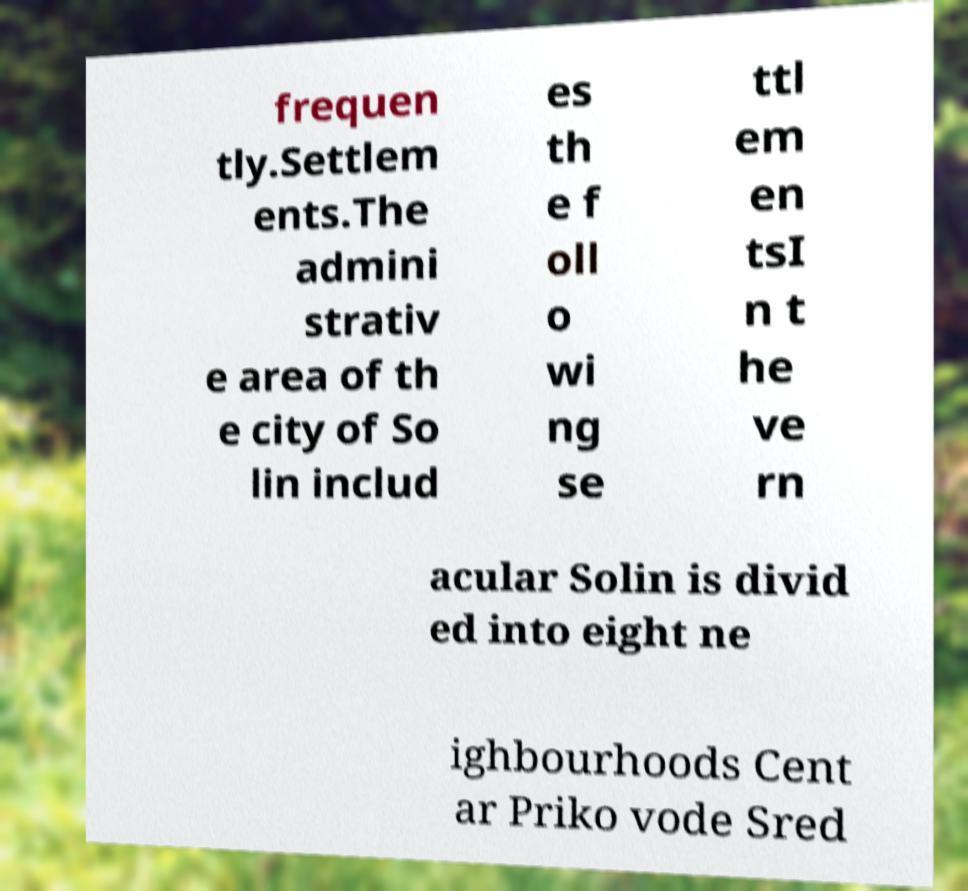Can you accurately transcribe the text from the provided image for me? frequen tly.Settlem ents.The admini strativ e area of th e city of So lin includ es th e f oll o wi ng se ttl em en tsI n t he ve rn acular Solin is divid ed into eight ne ighbourhoods Cent ar Priko vode Sred 